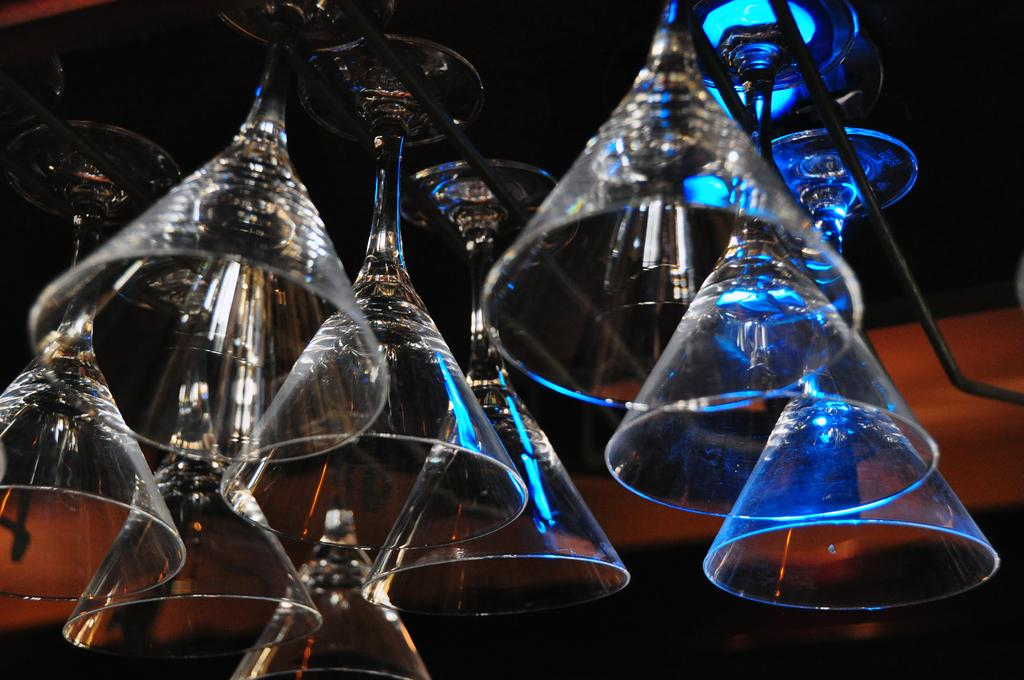What objects can be seen in the image? There are glasses and rods in the image. Can you describe the background of the image? The background of the image is blurry. How many dinosaurs can be seen in the image? There are no dinosaurs present in the image. What color is the eye of the person wearing the glasses in the image? There is no person wearing the glasses in the image, and therefore no eye to describe. 